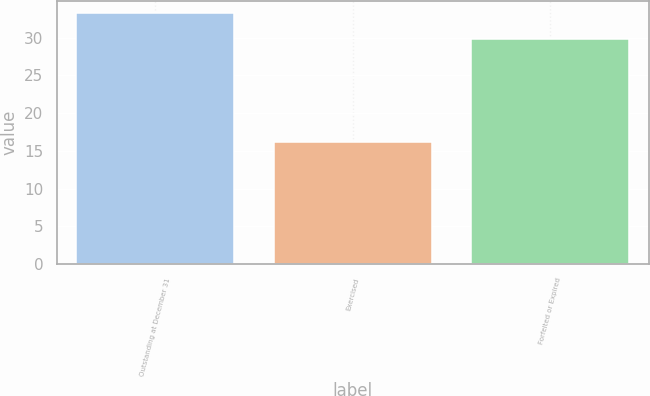<chart> <loc_0><loc_0><loc_500><loc_500><bar_chart><fcel>Outstanding at December 31<fcel>Exercised<fcel>Forfeited or Expired<nl><fcel>33.23<fcel>16.16<fcel>29.77<nl></chart> 